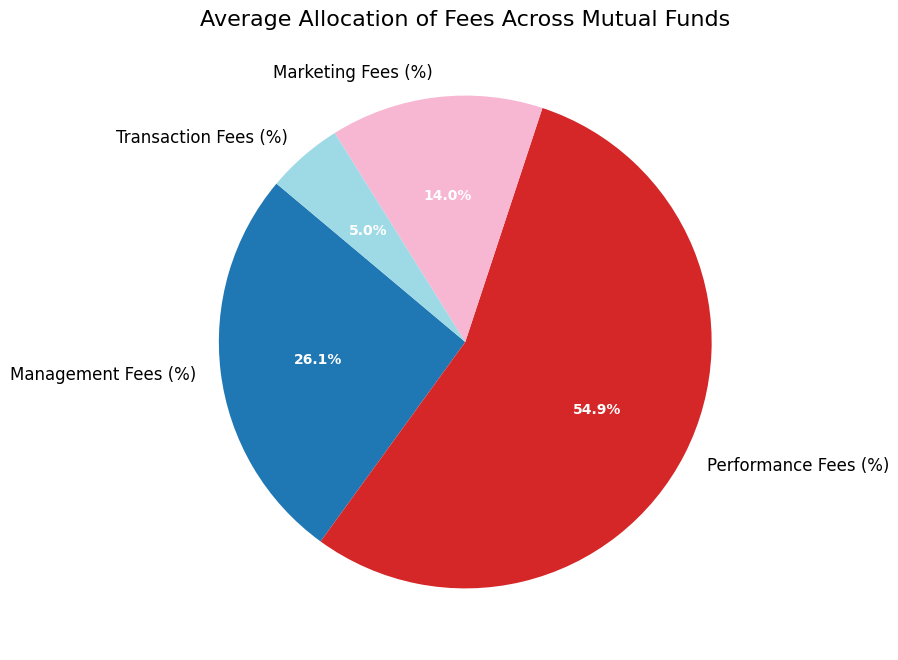What is the percentage of Performance Fees in the total average allocation? To find this, look at the pie chart section labeled "Performance Fees (%)" and note its percentage.
Answer: Approximately 44.0% Compare Management Fees and Transaction Fees: which is higher and by how much? First, find the percentages for both Management Fees and Transaction Fees sections in the pie chart. Then subtract the smaller percentage (Transaction Fees) from the larger one (Management Fees).
Answer: Management Fees are higher by approximately 16.7% What is the total percentage of Marketing Fees and Transaction Fees combined? Identify the percentages for Marketing Fees and Transaction Fees from the chart and add them together.
Answer: Approximately 15.9% Which fee category has the smallest average allocation? Look for the smallest percentage section in the pie chart.
Answer: Transaction Fees What is the difference in percentage between the highest and the lowest fee categories? Identify the highest percentage (Performance Fees) and the lowest percentage (Transaction Fees) in the pie chart. Subtract the lower percentage from the higher one.
Answer: Approximately 41.2% How does the percentage of Marketing Fees compare to that of Management Fees? Note both percentages from the pie chart. Compare the Marketing Fees percentage to the Management Fees percentage by subtraction.
Answer: Management Fees are approximately 4.1% higher than Marketing Fees 